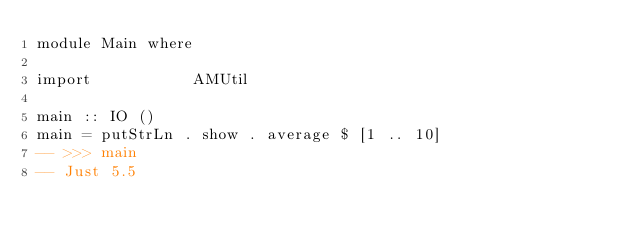Convert code to text. <code><loc_0><loc_0><loc_500><loc_500><_Haskell_>module Main where

import           AMUtil

main :: IO ()
main = putStrLn . show . average $ [1 .. 10]
-- >>> main
-- Just 5.5
</code> 